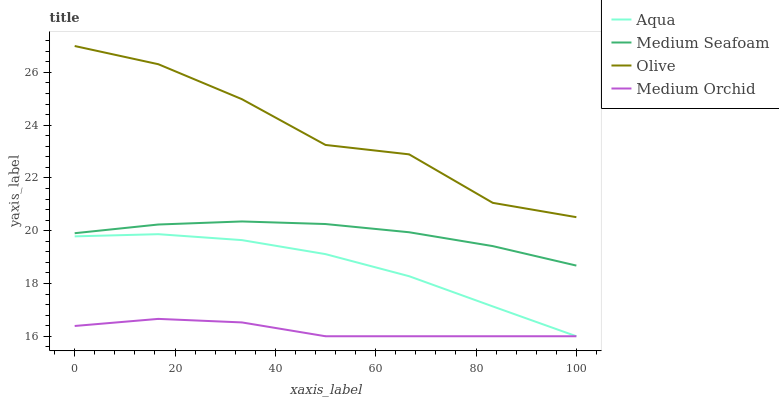Does Aqua have the minimum area under the curve?
Answer yes or no. No. Does Aqua have the maximum area under the curve?
Answer yes or no. No. Is Medium Orchid the smoothest?
Answer yes or no. No. Is Medium Orchid the roughest?
Answer yes or no. No. Does Medium Seafoam have the lowest value?
Answer yes or no. No. Does Aqua have the highest value?
Answer yes or no. No. Is Medium Seafoam less than Olive?
Answer yes or no. Yes. Is Medium Seafoam greater than Medium Orchid?
Answer yes or no. Yes. Does Medium Seafoam intersect Olive?
Answer yes or no. No. 